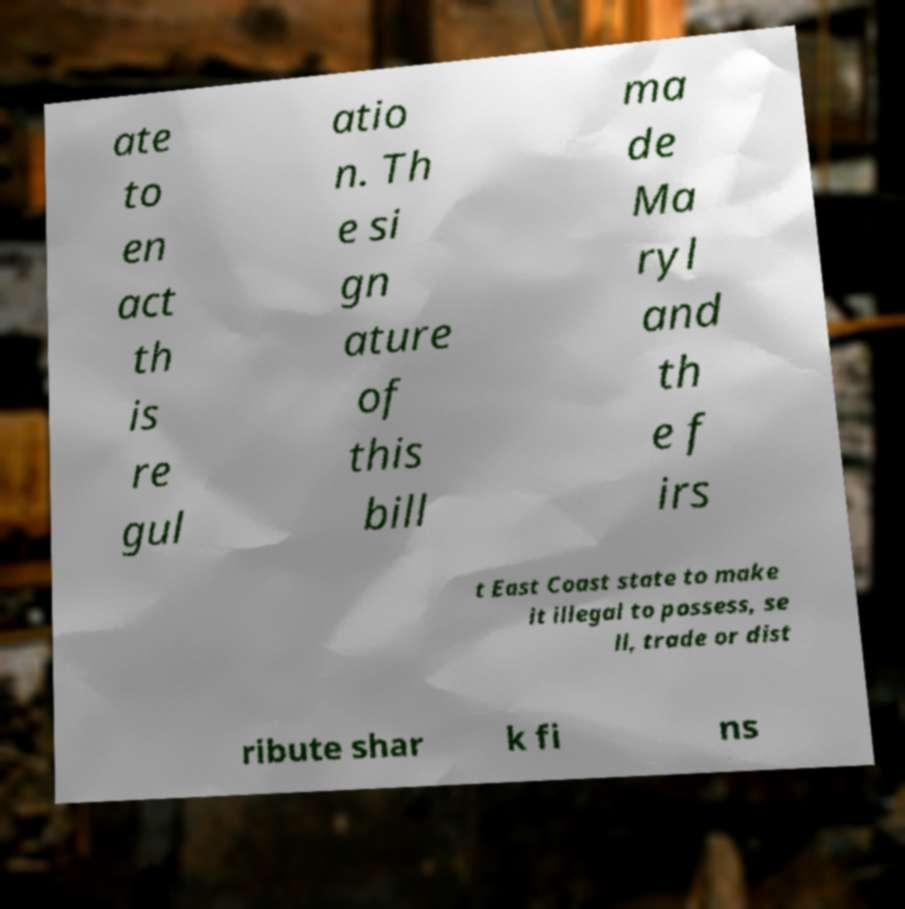Could you assist in decoding the text presented in this image and type it out clearly? ate to en act th is re gul atio n. Th e si gn ature of this bill ma de Ma ryl and th e f irs t East Coast state to make it illegal to possess, se ll, trade or dist ribute shar k fi ns 